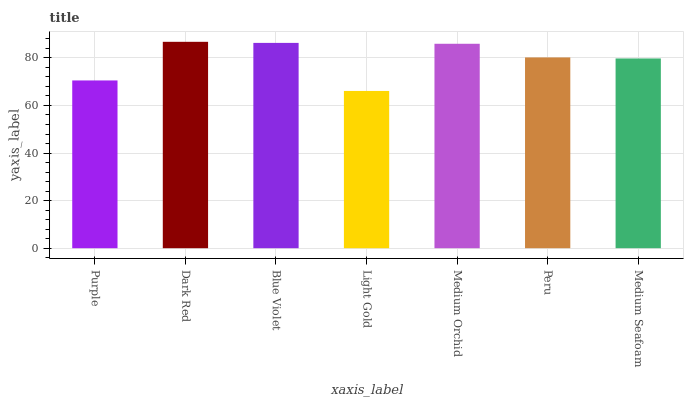Is Light Gold the minimum?
Answer yes or no. Yes. Is Dark Red the maximum?
Answer yes or no. Yes. Is Blue Violet the minimum?
Answer yes or no. No. Is Blue Violet the maximum?
Answer yes or no. No. Is Dark Red greater than Blue Violet?
Answer yes or no. Yes. Is Blue Violet less than Dark Red?
Answer yes or no. Yes. Is Blue Violet greater than Dark Red?
Answer yes or no. No. Is Dark Red less than Blue Violet?
Answer yes or no. No. Is Peru the high median?
Answer yes or no. Yes. Is Peru the low median?
Answer yes or no. Yes. Is Dark Red the high median?
Answer yes or no. No. Is Purple the low median?
Answer yes or no. No. 